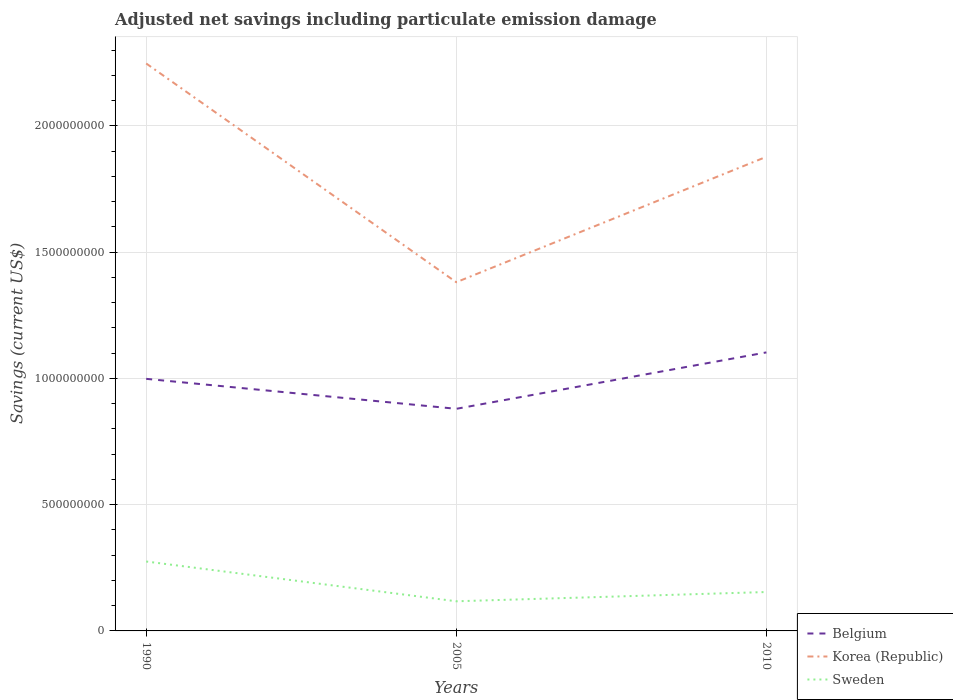How many different coloured lines are there?
Provide a short and direct response. 3. Does the line corresponding to Belgium intersect with the line corresponding to Sweden?
Give a very brief answer. No. Is the number of lines equal to the number of legend labels?
Provide a short and direct response. Yes. Across all years, what is the maximum net savings in Sweden?
Offer a very short reply. 1.17e+08. What is the total net savings in Belgium in the graph?
Your response must be concise. -2.23e+08. What is the difference between the highest and the second highest net savings in Sweden?
Offer a very short reply. 1.58e+08. Is the net savings in Belgium strictly greater than the net savings in Korea (Republic) over the years?
Your answer should be compact. Yes. How many lines are there?
Your response must be concise. 3. Are the values on the major ticks of Y-axis written in scientific E-notation?
Provide a short and direct response. No. Where does the legend appear in the graph?
Offer a very short reply. Bottom right. How many legend labels are there?
Make the answer very short. 3. What is the title of the graph?
Offer a very short reply. Adjusted net savings including particulate emission damage. What is the label or title of the Y-axis?
Give a very brief answer. Savings (current US$). What is the Savings (current US$) in Belgium in 1990?
Provide a succinct answer. 9.98e+08. What is the Savings (current US$) of Korea (Republic) in 1990?
Provide a succinct answer. 2.25e+09. What is the Savings (current US$) of Sweden in 1990?
Your answer should be very brief. 2.75e+08. What is the Savings (current US$) in Belgium in 2005?
Ensure brevity in your answer.  8.80e+08. What is the Savings (current US$) in Korea (Republic) in 2005?
Offer a terse response. 1.38e+09. What is the Savings (current US$) of Sweden in 2005?
Your answer should be compact. 1.17e+08. What is the Savings (current US$) in Belgium in 2010?
Your answer should be compact. 1.10e+09. What is the Savings (current US$) of Korea (Republic) in 2010?
Give a very brief answer. 1.88e+09. What is the Savings (current US$) of Sweden in 2010?
Provide a short and direct response. 1.54e+08. Across all years, what is the maximum Savings (current US$) in Belgium?
Provide a short and direct response. 1.10e+09. Across all years, what is the maximum Savings (current US$) in Korea (Republic)?
Your answer should be compact. 2.25e+09. Across all years, what is the maximum Savings (current US$) of Sweden?
Offer a terse response. 2.75e+08. Across all years, what is the minimum Savings (current US$) in Belgium?
Make the answer very short. 8.80e+08. Across all years, what is the minimum Savings (current US$) of Korea (Republic)?
Make the answer very short. 1.38e+09. Across all years, what is the minimum Savings (current US$) in Sweden?
Your answer should be compact. 1.17e+08. What is the total Savings (current US$) in Belgium in the graph?
Make the answer very short. 2.98e+09. What is the total Savings (current US$) in Korea (Republic) in the graph?
Provide a short and direct response. 5.51e+09. What is the total Savings (current US$) in Sweden in the graph?
Your answer should be very brief. 5.46e+08. What is the difference between the Savings (current US$) of Belgium in 1990 and that in 2005?
Ensure brevity in your answer.  1.19e+08. What is the difference between the Savings (current US$) of Korea (Republic) in 1990 and that in 2005?
Your response must be concise. 8.66e+08. What is the difference between the Savings (current US$) in Sweden in 1990 and that in 2005?
Your response must be concise. 1.58e+08. What is the difference between the Savings (current US$) of Belgium in 1990 and that in 2010?
Give a very brief answer. -1.05e+08. What is the difference between the Savings (current US$) in Korea (Republic) in 1990 and that in 2010?
Ensure brevity in your answer.  3.70e+08. What is the difference between the Savings (current US$) of Sweden in 1990 and that in 2010?
Make the answer very short. 1.21e+08. What is the difference between the Savings (current US$) of Belgium in 2005 and that in 2010?
Your answer should be very brief. -2.23e+08. What is the difference between the Savings (current US$) in Korea (Republic) in 2005 and that in 2010?
Your response must be concise. -4.97e+08. What is the difference between the Savings (current US$) in Sweden in 2005 and that in 2010?
Provide a succinct answer. -3.67e+07. What is the difference between the Savings (current US$) in Belgium in 1990 and the Savings (current US$) in Korea (Republic) in 2005?
Provide a short and direct response. -3.83e+08. What is the difference between the Savings (current US$) of Belgium in 1990 and the Savings (current US$) of Sweden in 2005?
Provide a succinct answer. 8.81e+08. What is the difference between the Savings (current US$) in Korea (Republic) in 1990 and the Savings (current US$) in Sweden in 2005?
Ensure brevity in your answer.  2.13e+09. What is the difference between the Savings (current US$) in Belgium in 1990 and the Savings (current US$) in Korea (Republic) in 2010?
Provide a short and direct response. -8.79e+08. What is the difference between the Savings (current US$) of Belgium in 1990 and the Savings (current US$) of Sweden in 2010?
Your answer should be very brief. 8.44e+08. What is the difference between the Savings (current US$) in Korea (Republic) in 1990 and the Savings (current US$) in Sweden in 2010?
Make the answer very short. 2.09e+09. What is the difference between the Savings (current US$) in Belgium in 2005 and the Savings (current US$) in Korea (Republic) in 2010?
Your response must be concise. -9.98e+08. What is the difference between the Savings (current US$) in Belgium in 2005 and the Savings (current US$) in Sweden in 2010?
Your answer should be very brief. 7.26e+08. What is the difference between the Savings (current US$) of Korea (Republic) in 2005 and the Savings (current US$) of Sweden in 2010?
Offer a very short reply. 1.23e+09. What is the average Savings (current US$) in Belgium per year?
Your response must be concise. 9.94e+08. What is the average Savings (current US$) in Korea (Republic) per year?
Ensure brevity in your answer.  1.84e+09. What is the average Savings (current US$) in Sweden per year?
Offer a very short reply. 1.82e+08. In the year 1990, what is the difference between the Savings (current US$) of Belgium and Savings (current US$) of Korea (Republic)?
Provide a succinct answer. -1.25e+09. In the year 1990, what is the difference between the Savings (current US$) in Belgium and Savings (current US$) in Sweden?
Provide a short and direct response. 7.23e+08. In the year 1990, what is the difference between the Savings (current US$) of Korea (Republic) and Savings (current US$) of Sweden?
Offer a terse response. 1.97e+09. In the year 2005, what is the difference between the Savings (current US$) in Belgium and Savings (current US$) in Korea (Republic)?
Your response must be concise. -5.01e+08. In the year 2005, what is the difference between the Savings (current US$) of Belgium and Savings (current US$) of Sweden?
Keep it short and to the point. 7.62e+08. In the year 2005, what is the difference between the Savings (current US$) of Korea (Republic) and Savings (current US$) of Sweden?
Ensure brevity in your answer.  1.26e+09. In the year 2010, what is the difference between the Savings (current US$) in Belgium and Savings (current US$) in Korea (Republic)?
Give a very brief answer. -7.75e+08. In the year 2010, what is the difference between the Savings (current US$) in Belgium and Savings (current US$) in Sweden?
Your response must be concise. 9.49e+08. In the year 2010, what is the difference between the Savings (current US$) of Korea (Republic) and Savings (current US$) of Sweden?
Provide a succinct answer. 1.72e+09. What is the ratio of the Savings (current US$) of Belgium in 1990 to that in 2005?
Your response must be concise. 1.13. What is the ratio of the Savings (current US$) in Korea (Republic) in 1990 to that in 2005?
Provide a succinct answer. 1.63. What is the ratio of the Savings (current US$) in Sweden in 1990 to that in 2005?
Offer a terse response. 2.34. What is the ratio of the Savings (current US$) of Belgium in 1990 to that in 2010?
Keep it short and to the point. 0.91. What is the ratio of the Savings (current US$) in Korea (Republic) in 1990 to that in 2010?
Your answer should be very brief. 1.2. What is the ratio of the Savings (current US$) in Sweden in 1990 to that in 2010?
Offer a terse response. 1.78. What is the ratio of the Savings (current US$) in Belgium in 2005 to that in 2010?
Keep it short and to the point. 0.8. What is the ratio of the Savings (current US$) in Korea (Republic) in 2005 to that in 2010?
Provide a short and direct response. 0.74. What is the ratio of the Savings (current US$) of Sweden in 2005 to that in 2010?
Make the answer very short. 0.76. What is the difference between the highest and the second highest Savings (current US$) of Belgium?
Ensure brevity in your answer.  1.05e+08. What is the difference between the highest and the second highest Savings (current US$) of Korea (Republic)?
Make the answer very short. 3.70e+08. What is the difference between the highest and the second highest Savings (current US$) in Sweden?
Provide a succinct answer. 1.21e+08. What is the difference between the highest and the lowest Savings (current US$) of Belgium?
Provide a succinct answer. 2.23e+08. What is the difference between the highest and the lowest Savings (current US$) in Korea (Republic)?
Ensure brevity in your answer.  8.66e+08. What is the difference between the highest and the lowest Savings (current US$) in Sweden?
Offer a very short reply. 1.58e+08. 